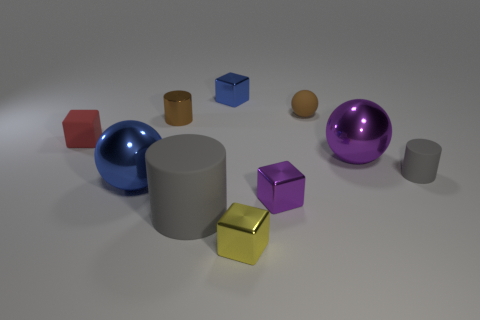Subtract all cylinders. How many objects are left? 7 Add 6 tiny blue blocks. How many tiny blue blocks are left? 7 Add 9 tiny brown shiny objects. How many tiny brown shiny objects exist? 10 Subtract 0 cyan cylinders. How many objects are left? 10 Subtract all tiny blocks. Subtract all gray matte objects. How many objects are left? 4 